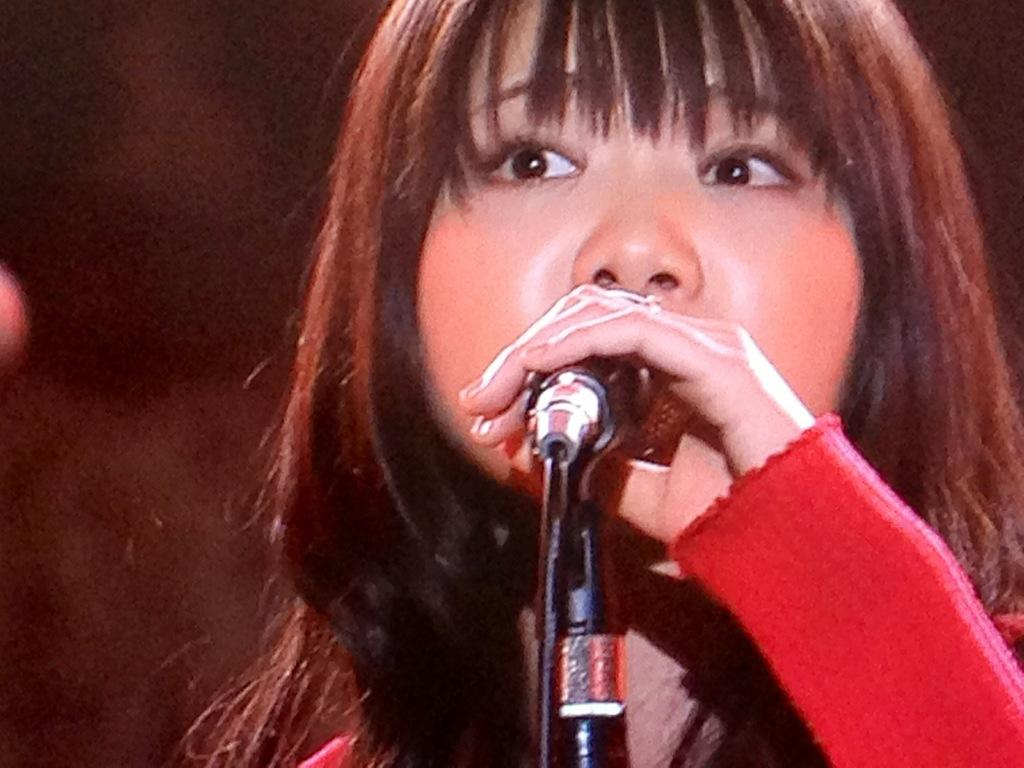Who is the main subject in the image? There is a girl in the image. What is the girl doing in the image? The girl is standing in front of a microphone and holding a microphone in her hand. What can be inferred about the girl's hair color from the image? The girl's hair color is light brown. How would you describe the background of the image? The background of the image is dark and blurry. Can you tell me how many times the girl bites the microphone in the image? There is no indication in the image that the girl is biting the microphone, so it cannot be determined from the picture. 